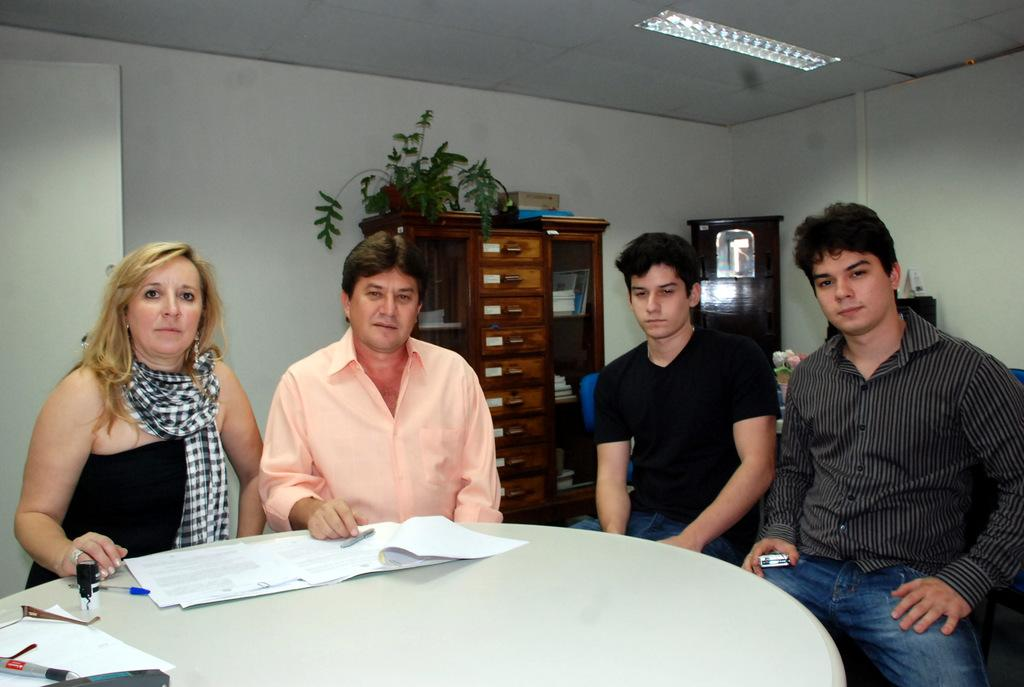How many people are in the image? There is a group of people in the image. What are the people doing in the image? The people are seated on chairs. What items can be seen on the table in the image? There are papers and pens on the table. What is located on the rack in the image? There is a plant on the rack. What type of berry is being served to the queen in the image? There is no queen or berry present in the image. 